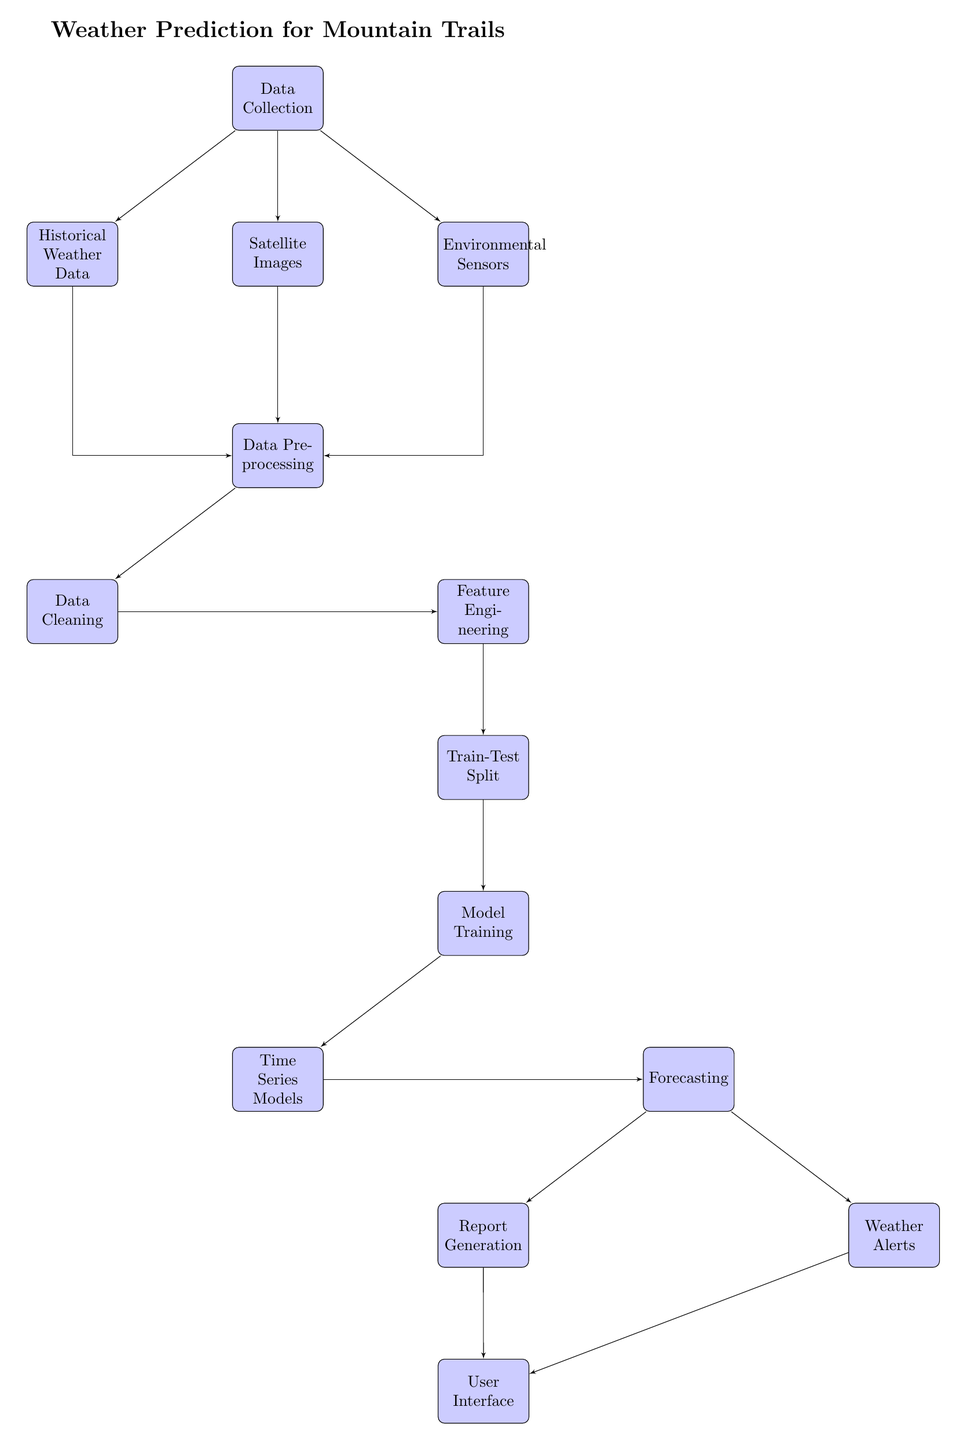What is the first step in the process? The first step in the diagram is "Data Collection," which is indicated as the topmost block and serves as the starting point for gathering the necessary input data.
Answer: Data Collection How many blocks are involved in the preprocessing stage? In the preprocessing stage, there are two blocks: "Data Cleaning" and "Feature Engineering." These blocks are those directly below the "Data Preprocessing" block.
Answer: 2 Which block is responsible for generating reports? The "Report Generation" block is responsible for generating reports, as it is directly linked to the "Forecasting" block, indicating that it produces output based on forecasts.
Answer: Report Generation What comes after Model Training in the sequence? After "Model Training," the next step is "Time Series Models." This is the direct next block in the sequence, showing how the model training is applied.
Answer: Time Series Models Which data input is NOT directly linked to the Preprocessing block? The "Historical Weather Data" is NOT directly linked to the "Data Preprocessing" block since it connects through a line that goes up to the "Data Collection" first, then routes down.
Answer: Historical Weather Data How does the flow from "Forecasting" reach the "User Interface"? The flow from "Forecasting" reaches the "User Interface" through two connections: one going to "Report Generation" and another going to "Weather Alerts," both of which feed into the "User Interface."
Answer: Through Report Generation and Weather Alerts What type of models are used in the training phase? The training phase uses "Time Series Models," as indicated in the block directly below "Model Training."
Answer: Time Series Models Which component collects the initial data inputs? "Data Collection" is the component responsible for collecting the initial data inputs from various sources like historical data, satellite images, and sensors.
Answer: Data Collection 